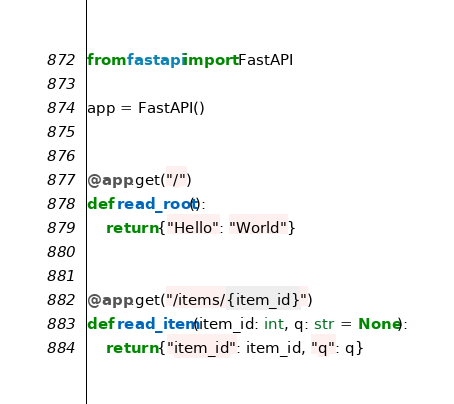<code> <loc_0><loc_0><loc_500><loc_500><_Python_>from fastapi import FastAPI

app = FastAPI()


@app.get("/")
def read_root():
    return {"Hello": "World"}


@app.get("/items/{item_id}")
def read_item(item_id: int, q: str = None):
    return {"item_id": item_id, "q": q}
</code> 